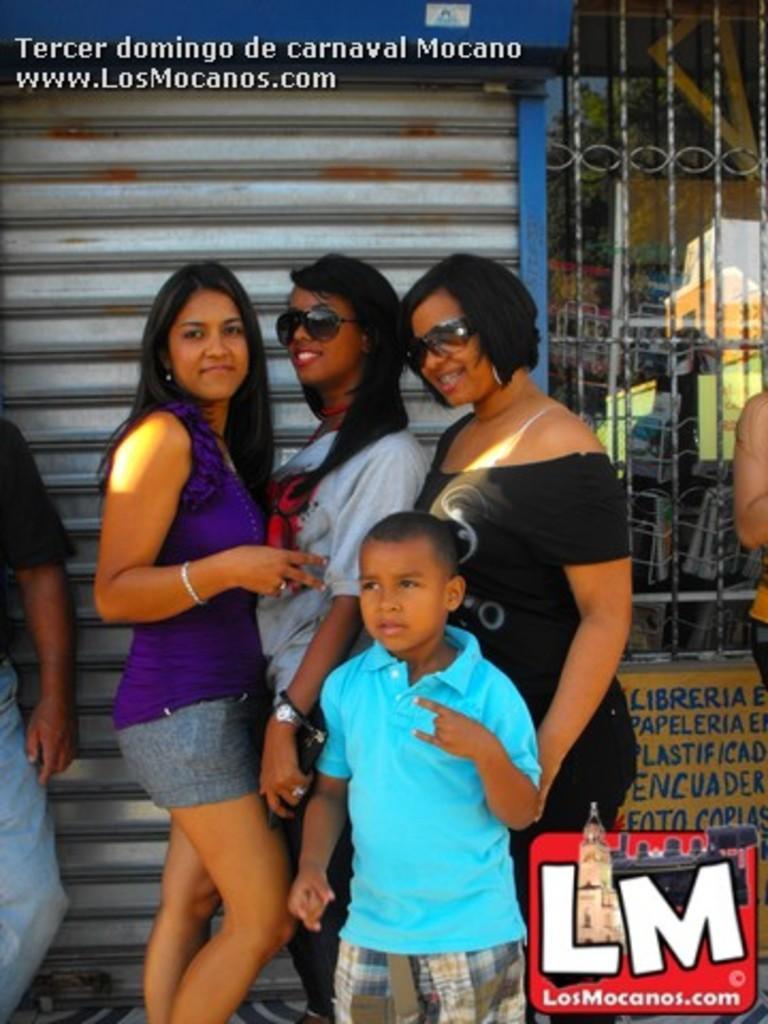In one or two sentences, can you explain what this image depicts? Here I can see three women and a boy are standing, smiling and giving pose for the picture. On the right and left side of the image I can see two persons. At the back of these people there is a shutter and a metal frame. In the bottom right-hand corner there is a logo. At the top of the image there is some text. 